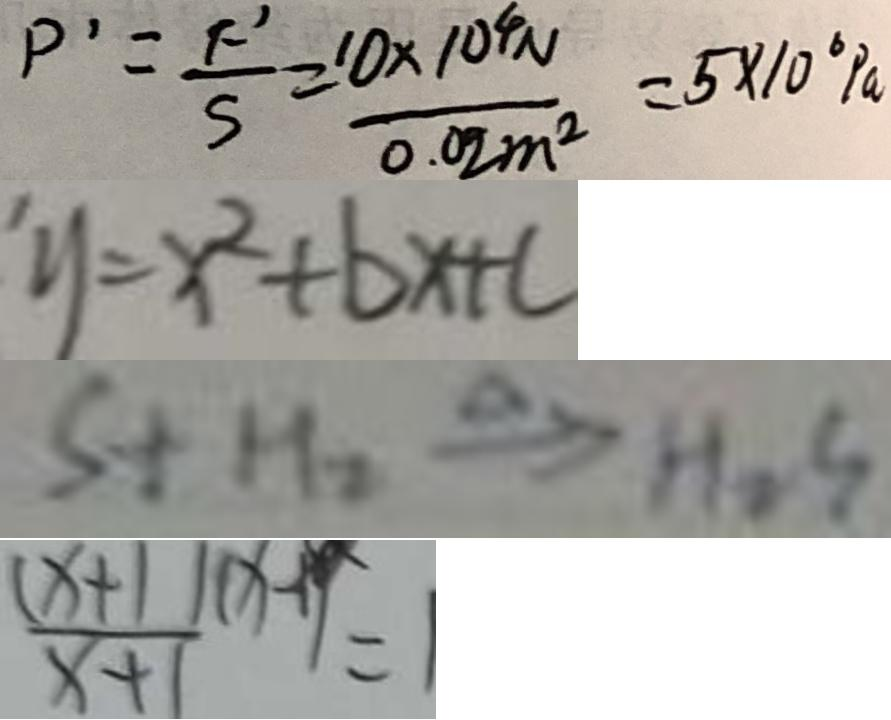<formula> <loc_0><loc_0><loc_500><loc_500>P ^ { \prime } = \frac { F ^ { \prime } } { S } = \frac { 1 0 \times 1 0 ^ { 4 } N } { 0 . 0 2 m ^ { 2 } } = 5 \times 1 0 ^ { 6 } P a 
 y = x ^ { 2 } + b x + c 
 S + H _ { 2 } \xrightarrow { \Delta } H _ { 2 } S 
 \frac { ( x + 1 ) ( x - 1 ) } { x + 1 } = 1</formula> 